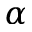Convert formula to latex. <formula><loc_0><loc_0><loc_500><loc_500>\alpha</formula> 